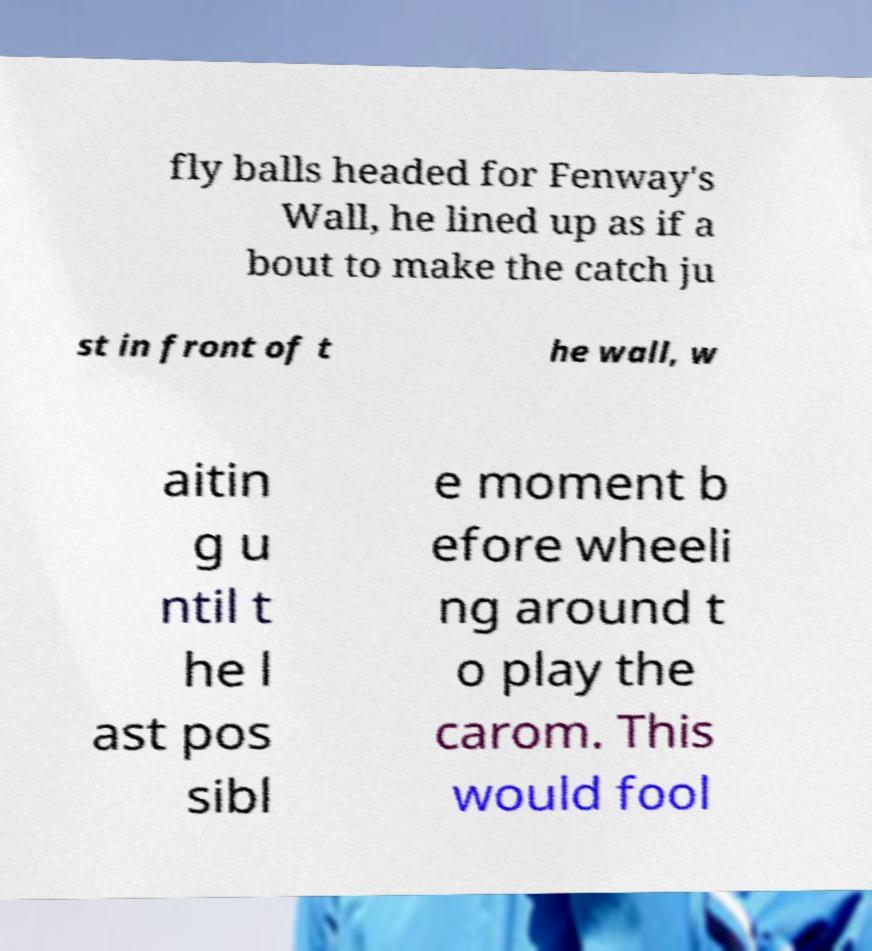There's text embedded in this image that I need extracted. Can you transcribe it verbatim? fly balls headed for Fenway's Wall, he lined up as if a bout to make the catch ju st in front of t he wall, w aitin g u ntil t he l ast pos sibl e moment b efore wheeli ng around t o play the carom. This would fool 